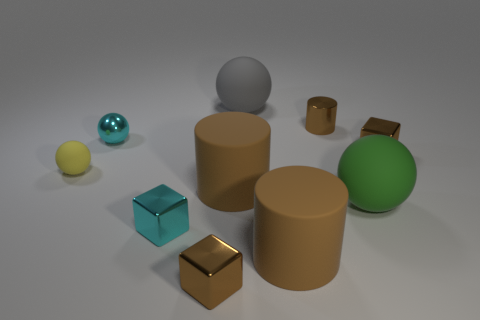How many other objects are the same material as the big gray thing?
Keep it short and to the point. 4. Is the number of yellow cubes greater than the number of brown cubes?
Your response must be concise. No. What is the material of the brown block that is in front of the shiny block that is on the left side of the small brown metallic object that is left of the gray thing?
Provide a short and direct response. Metal. Is the shiny cylinder the same color as the metal sphere?
Your answer should be very brief. No. Is there a big matte cylinder that has the same color as the small matte object?
Make the answer very short. No. There is a yellow thing that is the same size as the cyan ball; what is its shape?
Make the answer very short. Sphere. Is the number of tiny cyan objects less than the number of brown cylinders?
Ensure brevity in your answer.  Yes. What number of shiny spheres are the same size as the green object?
Offer a terse response. 0. There is a metallic thing that is the same color as the small metallic ball; what is its shape?
Provide a succinct answer. Cube. What material is the large gray object?
Provide a succinct answer. Rubber. 